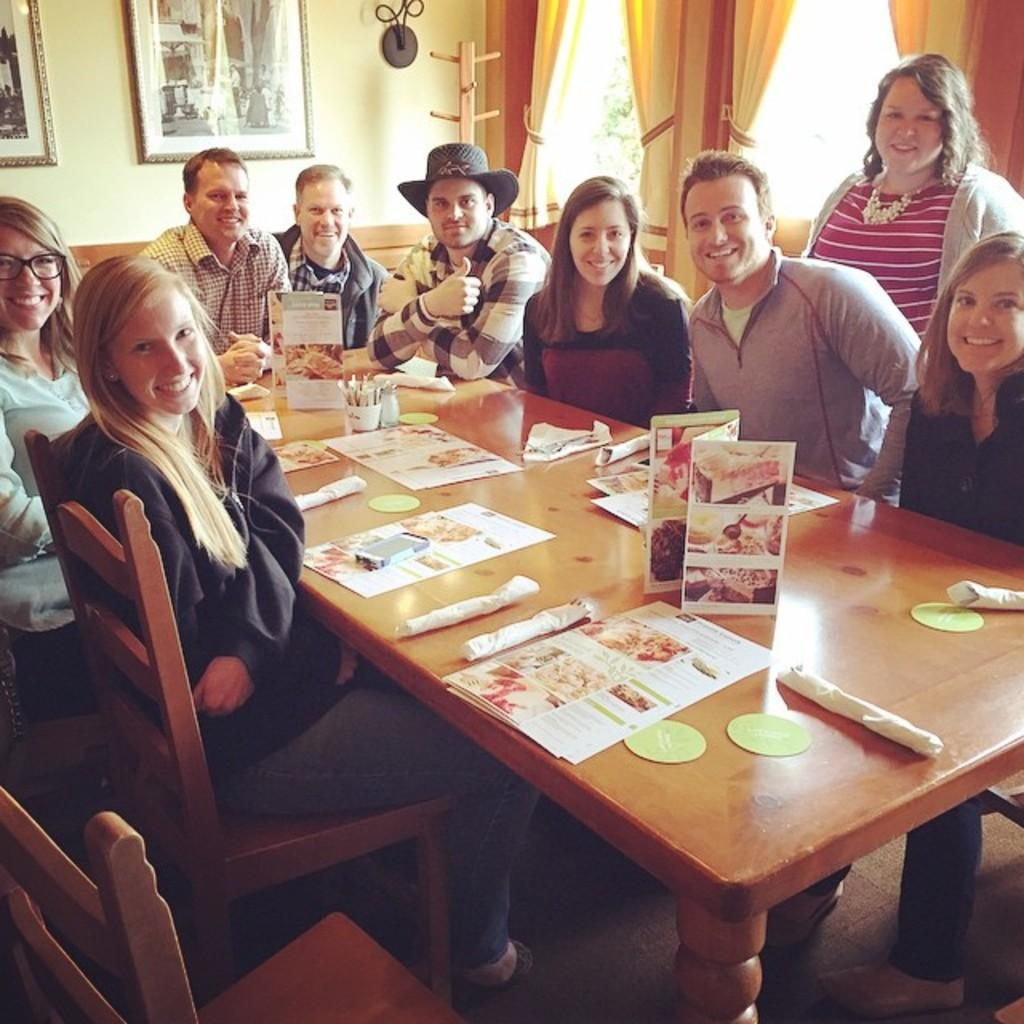What is happening in the image involving a group of people? There is a group of people in the image, and they are seated on chairs. How are the people in the image feeling or expressing themselves? The people in the image have smiles on their faces, indicating that they are happy or enjoying themselves. What can be seen on the table in the image? There are papers on the table in the image. What is hanging on the wall in the image? There are photo frames on the wall in the image. What type of quill is being used by the people in the image? There is no quill present in the image; the people are not writing or drawing. What color paint is being used by the people in the image? There is no paint or painting activity depicted in the image. 